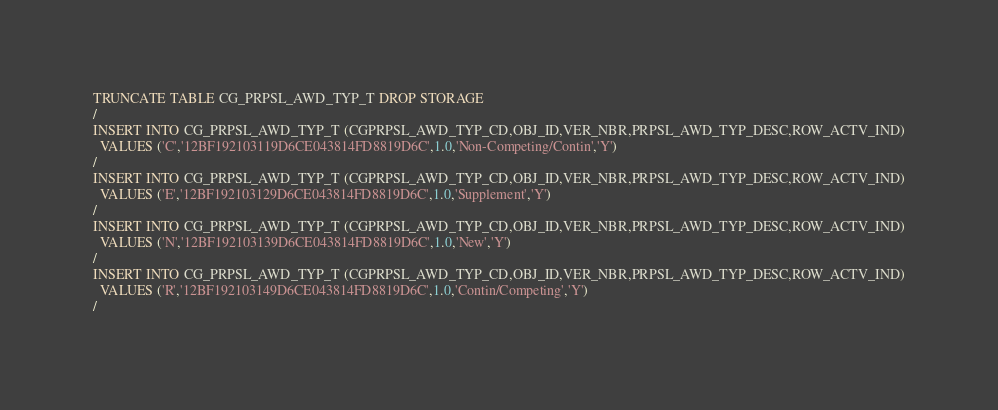Convert code to text. <code><loc_0><loc_0><loc_500><loc_500><_SQL_>TRUNCATE TABLE CG_PRPSL_AWD_TYP_T DROP STORAGE
/
INSERT INTO CG_PRPSL_AWD_TYP_T (CGPRPSL_AWD_TYP_CD,OBJ_ID,VER_NBR,PRPSL_AWD_TYP_DESC,ROW_ACTV_IND)
  VALUES ('C','12BF192103119D6CE043814FD8819D6C',1.0,'Non-Competing/Contin','Y')
/
INSERT INTO CG_PRPSL_AWD_TYP_T (CGPRPSL_AWD_TYP_CD,OBJ_ID,VER_NBR,PRPSL_AWD_TYP_DESC,ROW_ACTV_IND)
  VALUES ('E','12BF192103129D6CE043814FD8819D6C',1.0,'Supplement','Y')
/
INSERT INTO CG_PRPSL_AWD_TYP_T (CGPRPSL_AWD_TYP_CD,OBJ_ID,VER_NBR,PRPSL_AWD_TYP_DESC,ROW_ACTV_IND)
  VALUES ('N','12BF192103139D6CE043814FD8819D6C',1.0,'New','Y')
/
INSERT INTO CG_PRPSL_AWD_TYP_T (CGPRPSL_AWD_TYP_CD,OBJ_ID,VER_NBR,PRPSL_AWD_TYP_DESC,ROW_ACTV_IND)
  VALUES ('R','12BF192103149D6CE043814FD8819D6C',1.0,'Contin/Competing','Y')
/
</code> 